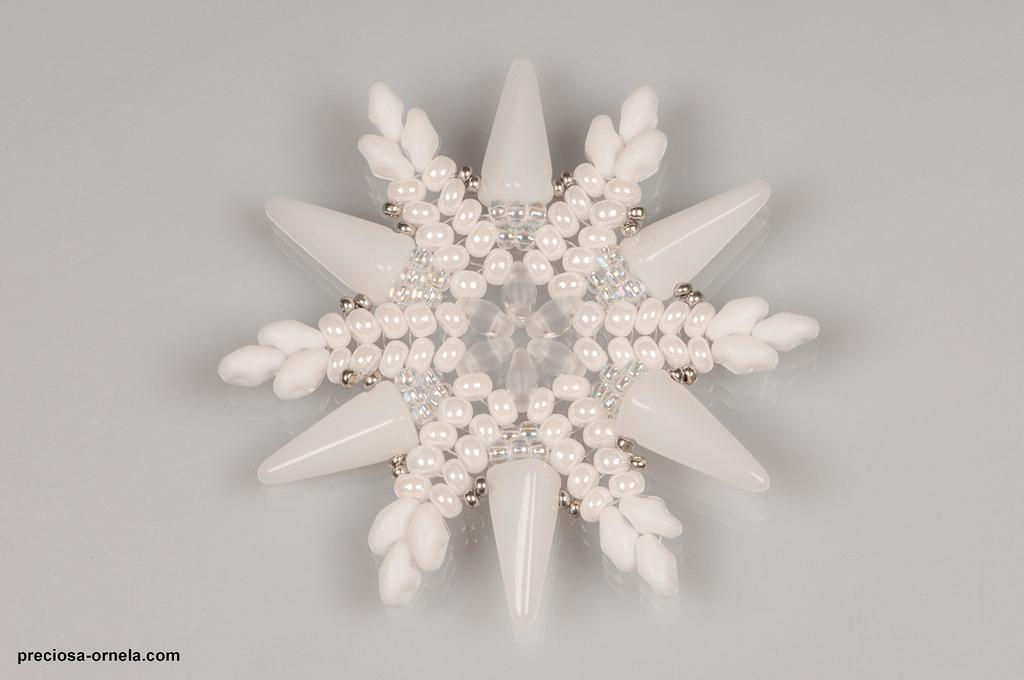What is the main subject in the foreground of the image? There are beads arranged in the foreground of the image. How are the beads arranged? The beads are arranged in the shape of a flower model. What is the color of the surface on which the arrangement is placed? The arrangement is on a white surface. Can you tell me how many times the grandfather has worn the beaded wristband in the image? There is no wristband or grandfather present in the image; it features an arrangement of beads in the shape of a flower model on a white surface. 